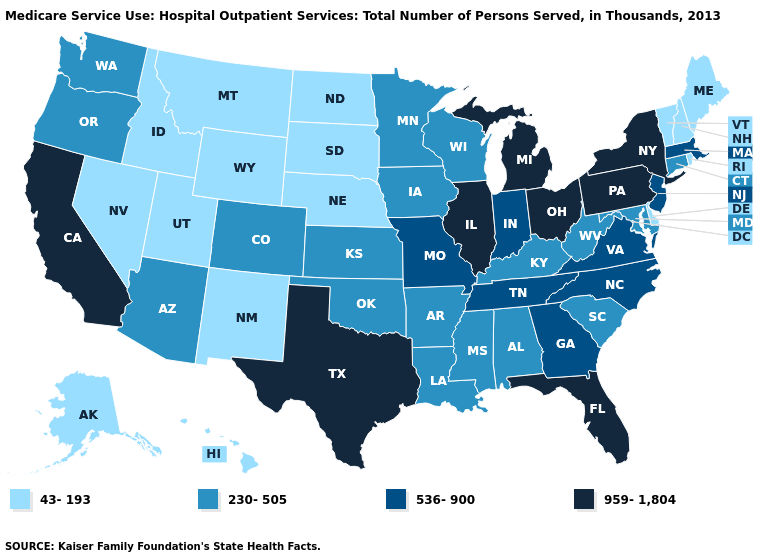Name the states that have a value in the range 959-1,804?
Be succinct. California, Florida, Illinois, Michigan, New York, Ohio, Pennsylvania, Texas. Which states have the highest value in the USA?
Give a very brief answer. California, Florida, Illinois, Michigan, New York, Ohio, Pennsylvania, Texas. Name the states that have a value in the range 230-505?
Give a very brief answer. Alabama, Arizona, Arkansas, Colorado, Connecticut, Iowa, Kansas, Kentucky, Louisiana, Maryland, Minnesota, Mississippi, Oklahoma, Oregon, South Carolina, Washington, West Virginia, Wisconsin. Name the states that have a value in the range 959-1,804?
Keep it brief. California, Florida, Illinois, Michigan, New York, Ohio, Pennsylvania, Texas. Name the states that have a value in the range 959-1,804?
Concise answer only. California, Florida, Illinois, Michigan, New York, Ohio, Pennsylvania, Texas. Does Louisiana have the highest value in the USA?
Give a very brief answer. No. Name the states that have a value in the range 230-505?
Write a very short answer. Alabama, Arizona, Arkansas, Colorado, Connecticut, Iowa, Kansas, Kentucky, Louisiana, Maryland, Minnesota, Mississippi, Oklahoma, Oregon, South Carolina, Washington, West Virginia, Wisconsin. Among the states that border Colorado , which have the lowest value?
Quick response, please. Nebraska, New Mexico, Utah, Wyoming. Name the states that have a value in the range 230-505?
Answer briefly. Alabama, Arizona, Arkansas, Colorado, Connecticut, Iowa, Kansas, Kentucky, Louisiana, Maryland, Minnesota, Mississippi, Oklahoma, Oregon, South Carolina, Washington, West Virginia, Wisconsin. What is the value of Michigan?
Write a very short answer. 959-1,804. Name the states that have a value in the range 230-505?
Keep it brief. Alabama, Arizona, Arkansas, Colorado, Connecticut, Iowa, Kansas, Kentucky, Louisiana, Maryland, Minnesota, Mississippi, Oklahoma, Oregon, South Carolina, Washington, West Virginia, Wisconsin. Does the map have missing data?
Concise answer only. No. Which states hav the highest value in the MidWest?
Concise answer only. Illinois, Michigan, Ohio. What is the value of Missouri?
Short answer required. 536-900. Does the map have missing data?
Be succinct. No. 